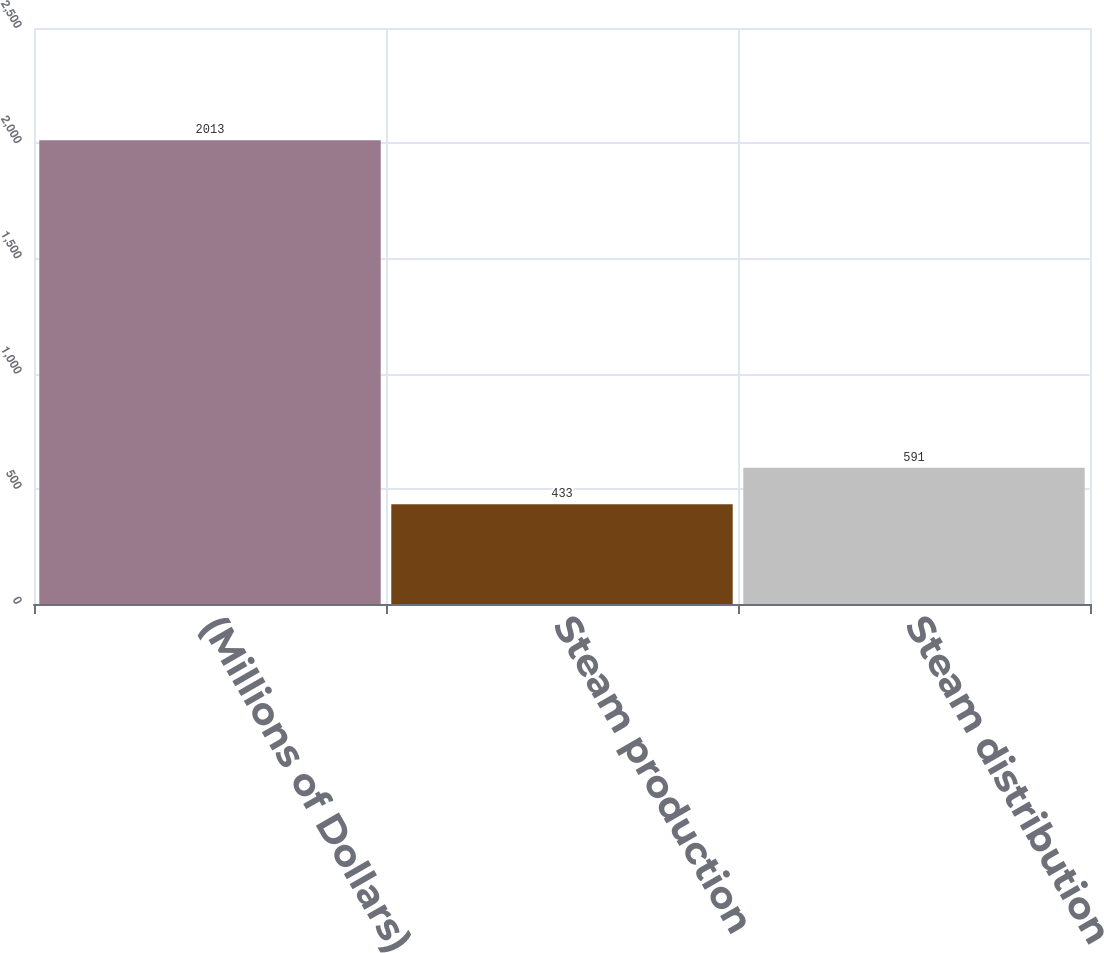<chart> <loc_0><loc_0><loc_500><loc_500><bar_chart><fcel>(Millions of Dollars)<fcel>Steam production<fcel>Steam distribution<nl><fcel>2013<fcel>433<fcel>591<nl></chart> 